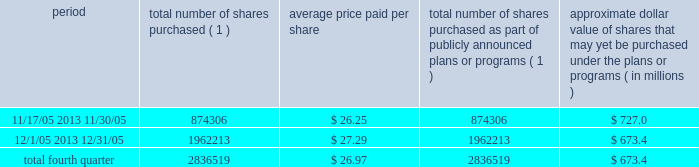Discussion and analysis of financial condition and results of operations 2014liquidity and capital resources 2014 factors affecting sources of liquidity . 201d recent sales of unregistered securities during the year ended december 31 , 2005 , we issued an aggregate of 4670335 shares of our class a common stock upon conversion of $ 57.1 million principal amount of our 3.25% ( 3.25 % ) notes .
Pursuant to the terms of the indenture , the holders of the 3.25% ( 3.25 % ) notes received 81.808 shares of class a common stock for every $ 1000 principal amount of notes converted .
The shares were issued to the noteholders in reliance on the exemption from registration set forth in section 3 ( a ) ( 9 ) of the securities act of 1933 , as amended .
No underwriters were engaged in connection with such issuances .
In connection with the conversion , we paid such holders an aggregate of $ 4.9 million , calculated based on the accrued and unpaid interest on the notes and the discounted value of the future interest payments on the notes .
Subsequent to december 31 , 2005 , we issued shares of class a common stock upon conversions of additional 3.25% ( 3.25 % ) notes , as set forth in item 9b of this annual report under the caption 201cother information . 201d during the year ended december 31 , 2005 , we issued an aggregate of 398412 shares of our class a common stock upon exercises of 55729 warrants assumed in our merger with spectrasite , inc .
In august 2005 , in connection with our merger with spectrasite , inc. , we assumed approximately 1.0 million warrants to purchase shares of spectrasite , inc .
Common stock .
Upon completion of the merger , each warrant to purchase shares of spectrasite , inc .
Common stock automatically converted into a warrant to purchase 7.15 shares of class a common stock at an exercise price of $ 32 per warrant .
Net proceeds from these warrant exercises were approximately $ 1.8 million .
The shares of class a common stock issued to the warrantholders upon exercise of the warrants were issued in reliance on the exemption from registration set forth in section 3 ( a ) ( 9 ) of the securities act of 1933 , as amended .
No underwriters were engaged in connection with such issuances .
Subsequent to december 31 , 2005 , we issued shares of class a common stock upon exercises of additional warrants , as set forth in item 9b of this annual report under the caption 201cother information . 201d issuer purchases of equity securities in november 2005 , we announced that our board of directors had approved a stock repurchase program pursuant to which we intend to repurchase up to $ 750.0 million of our class a common stock through december 2006 .
During the fourth quarter of 2005 , we repurchased 2836519 shares of our class a common stock for an aggregate of $ 76.6 million pursuant to our stock repurchase program , as follows : period total number of shares purchased ( 1 ) average price paid per share total number of shares purchased as part of publicly announced plans or programs ( 1 ) approximate dollar value of shares that may yet be purchased under the plans or programs ( in millions ) .
( 1 ) all issuer repurchases were made pursuant to the stock repurchase program publicly announced in november 2005 .
Pursuant to the program , we intend to repurchase up to $ 750.0 million of our class a common stock during the period november 2005 through december 2006 .
Under the program , our management is authorized to purchase shares from time to time in open market purchases or privately negotiated transactions at prevailing prices as permitted by securities laws and other legal requirements , and subject to market conditions and other factors .
To facilitate repurchases , we entered into a trading plan under rule 10b5-1 of the securities exchange act of 1934 , which allows us to repurchase shares during periods when we otherwise might be prevented from doing so under insider trading laws or because of self- imposed trading blackout periods .
The program may be discontinued at any time .
Since december 31 , 2005 , we have continued to repurchase shares of our class a common stock pursuant to our stock repurchase program .
Between january 1 , 2006 and march 9 , 2006 , we repurchased 3.9 million shares of class a common stock for an aggregate of $ 117.4 million pursuant to the stock repurchase program. .
Based on the information what was the number of stock warrants issued for the purchase of spectrasite , inc? 
Computations: (1.8 / 32)
Answer: 0.05625. 